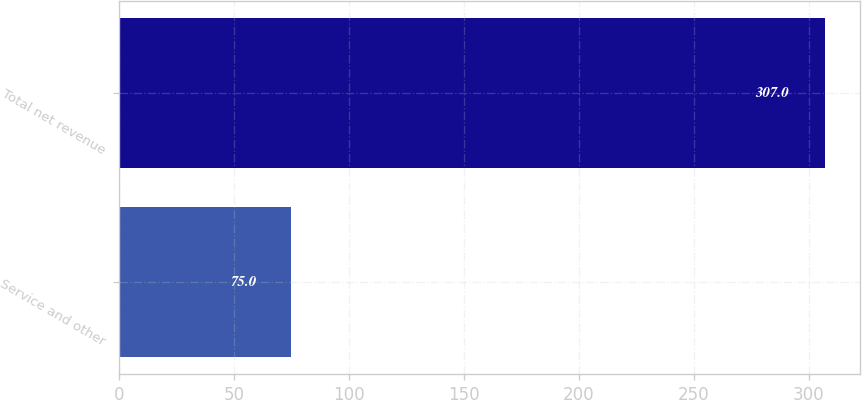Convert chart. <chart><loc_0><loc_0><loc_500><loc_500><bar_chart><fcel>Service and other<fcel>Total net revenue<nl><fcel>75<fcel>307<nl></chart> 